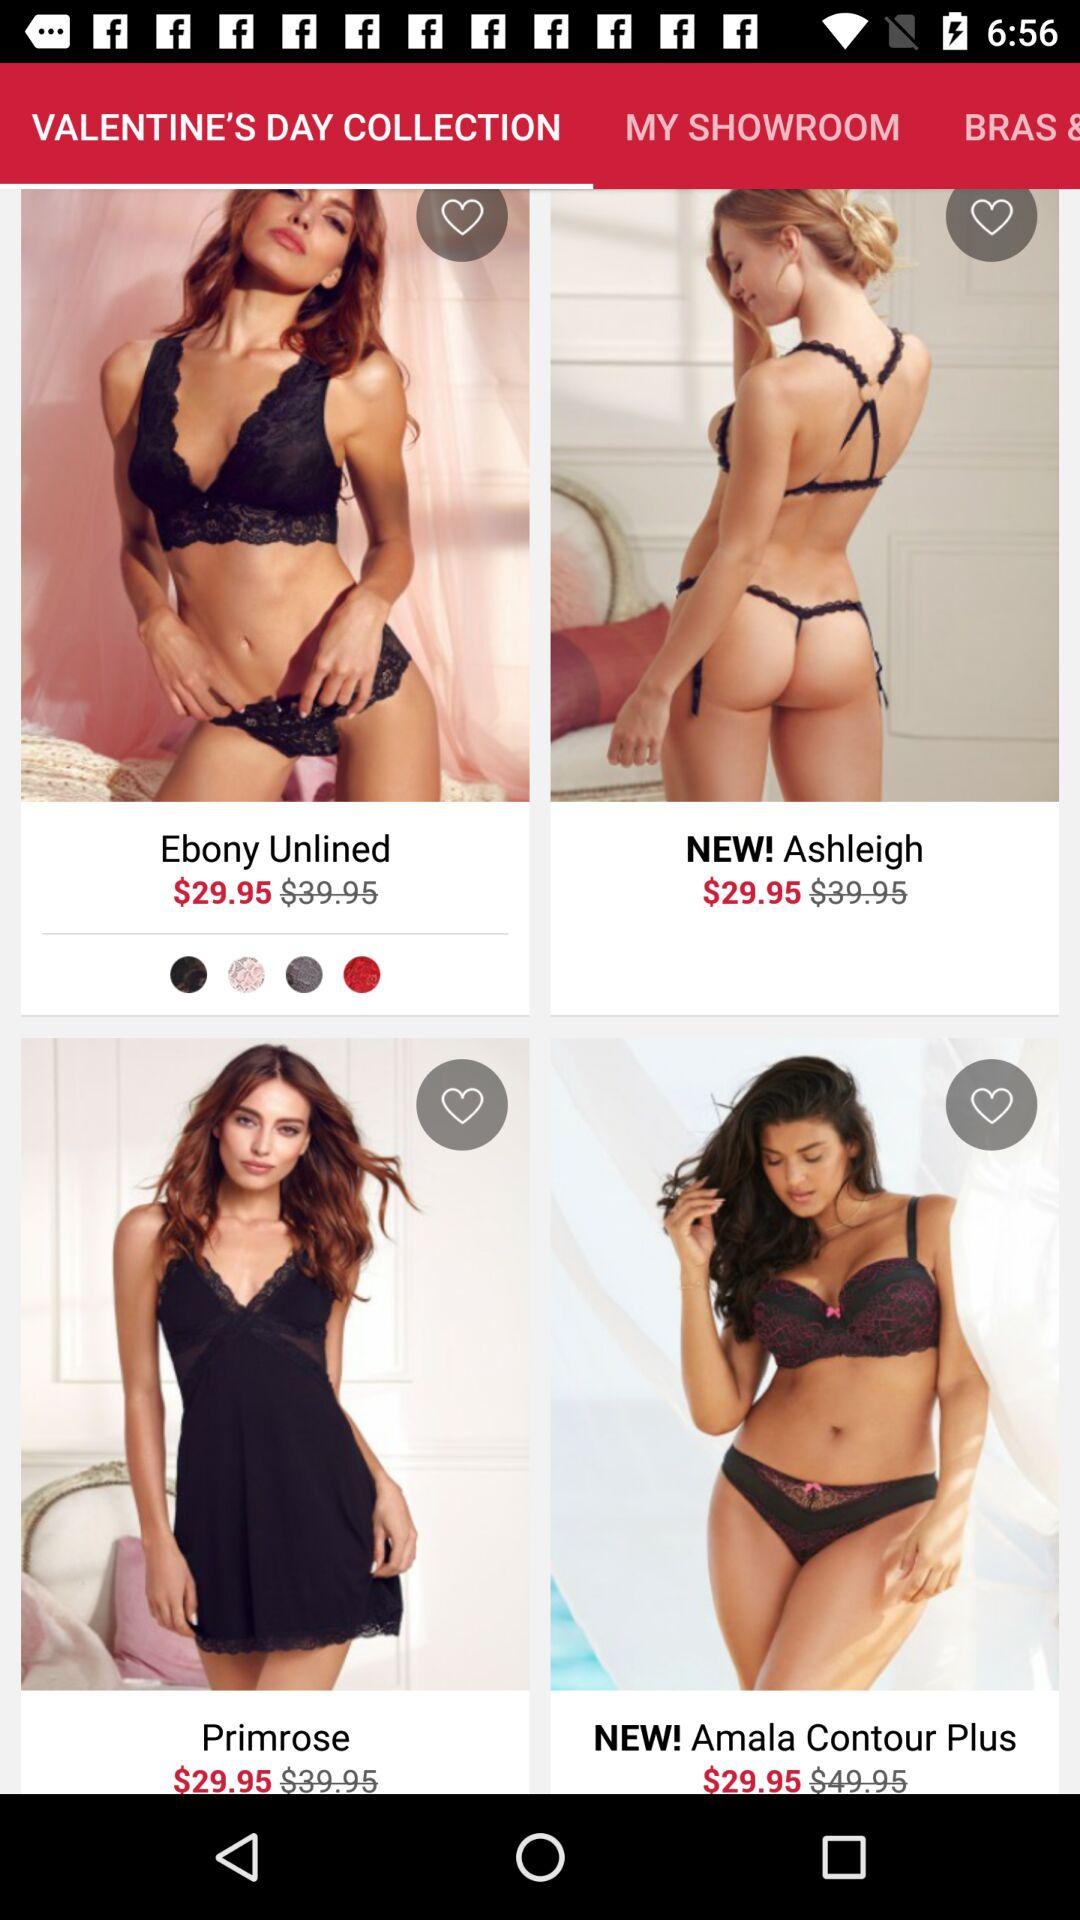What tab is selected? The selected tab is "VALENTINE'S DAY COLLECTION". 